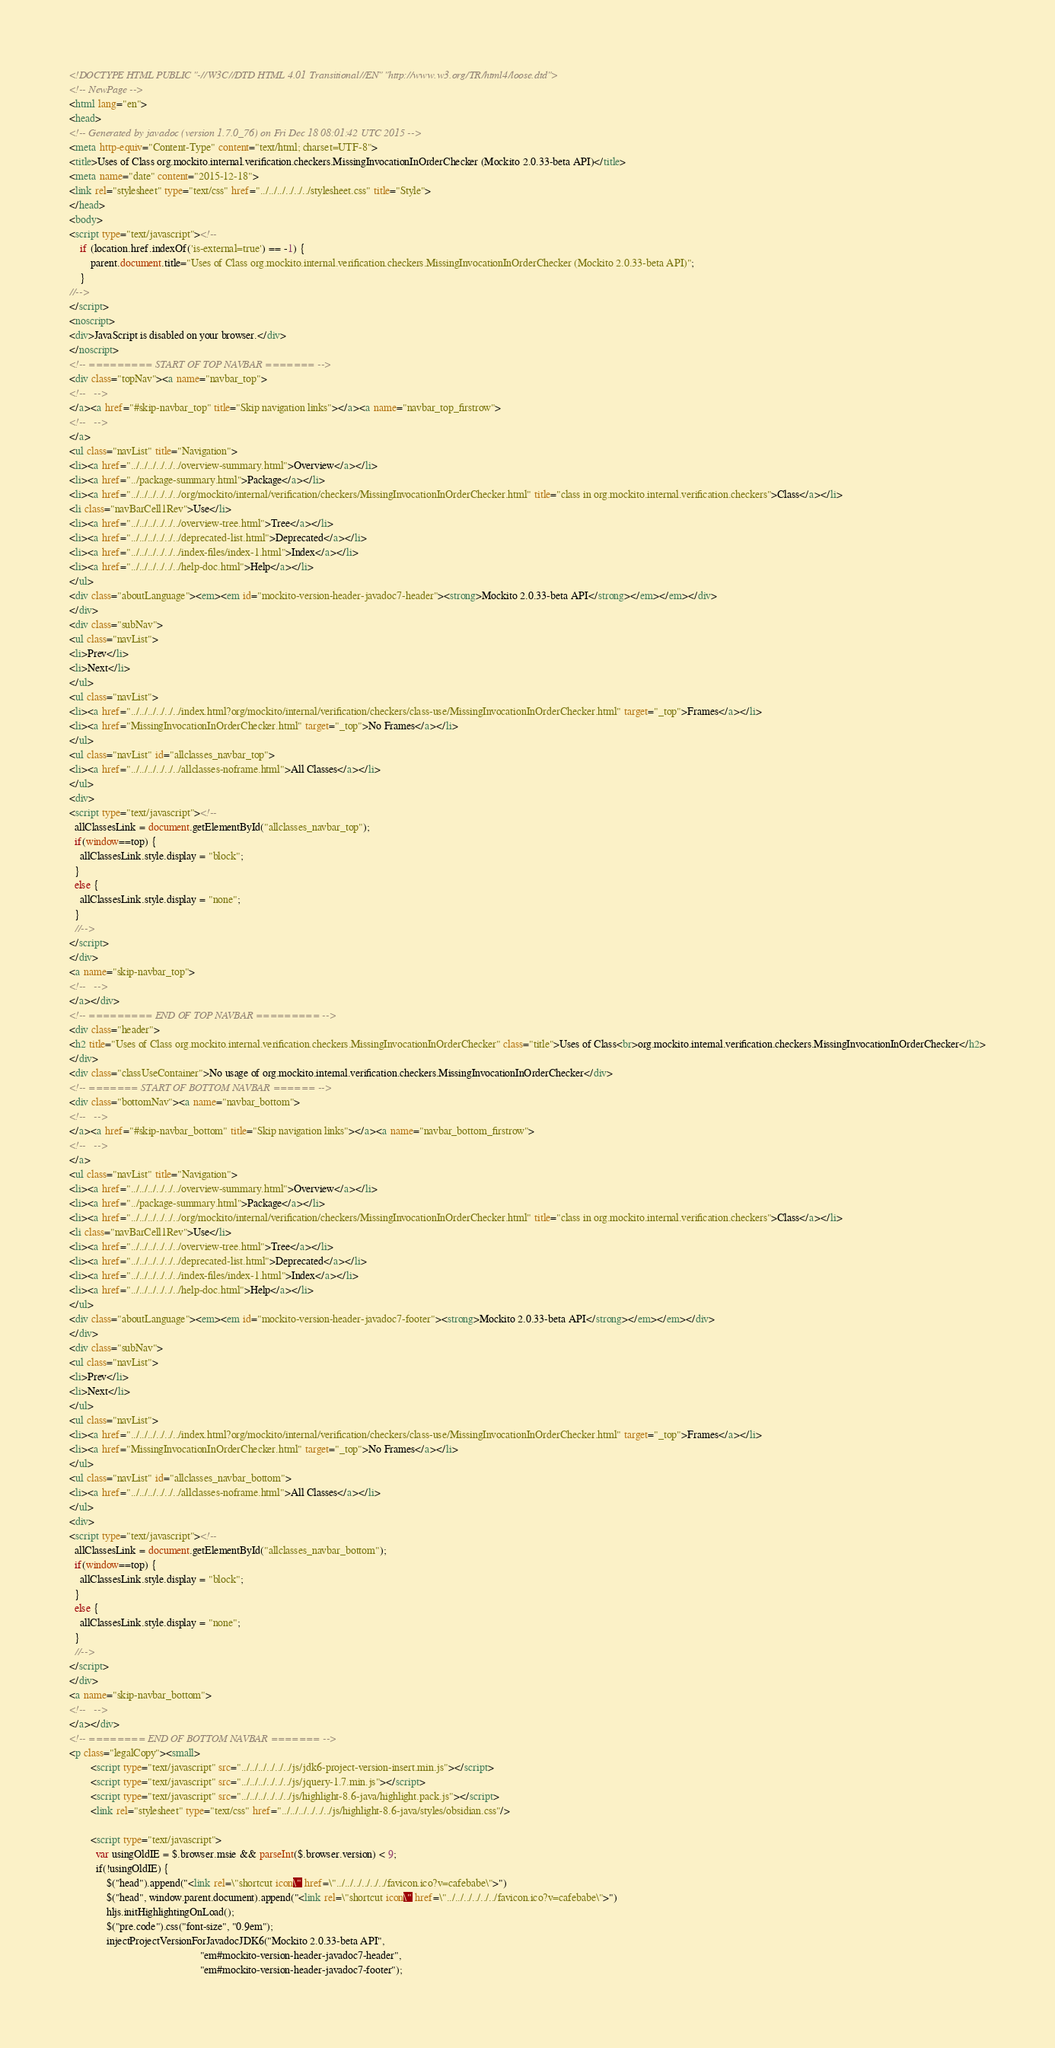Convert code to text. <code><loc_0><loc_0><loc_500><loc_500><_HTML_><!DOCTYPE HTML PUBLIC "-//W3C//DTD HTML 4.01 Transitional//EN" "http://www.w3.org/TR/html4/loose.dtd">
<!-- NewPage -->
<html lang="en">
<head>
<!-- Generated by javadoc (version 1.7.0_76) on Fri Dec 18 08:01:42 UTC 2015 -->
<meta http-equiv="Content-Type" content="text/html; charset=UTF-8">
<title>Uses of Class org.mockito.internal.verification.checkers.MissingInvocationInOrderChecker (Mockito 2.0.33-beta API)</title>
<meta name="date" content="2015-12-18">
<link rel="stylesheet" type="text/css" href="../../../../../../stylesheet.css" title="Style">
</head>
<body>
<script type="text/javascript"><!--
    if (location.href.indexOf('is-external=true') == -1) {
        parent.document.title="Uses of Class org.mockito.internal.verification.checkers.MissingInvocationInOrderChecker (Mockito 2.0.33-beta API)";
    }
//-->
</script>
<noscript>
<div>JavaScript is disabled on your browser.</div>
</noscript>
<!-- ========= START OF TOP NAVBAR ======= -->
<div class="topNav"><a name="navbar_top">
<!--   -->
</a><a href="#skip-navbar_top" title="Skip navigation links"></a><a name="navbar_top_firstrow">
<!--   -->
</a>
<ul class="navList" title="Navigation">
<li><a href="../../../../../../overview-summary.html">Overview</a></li>
<li><a href="../package-summary.html">Package</a></li>
<li><a href="../../../../../../org/mockito/internal/verification/checkers/MissingInvocationInOrderChecker.html" title="class in org.mockito.internal.verification.checkers">Class</a></li>
<li class="navBarCell1Rev">Use</li>
<li><a href="../../../../../../overview-tree.html">Tree</a></li>
<li><a href="../../../../../../deprecated-list.html">Deprecated</a></li>
<li><a href="../../../../../../index-files/index-1.html">Index</a></li>
<li><a href="../../../../../../help-doc.html">Help</a></li>
</ul>
<div class="aboutLanguage"><em><em id="mockito-version-header-javadoc7-header"><strong>Mockito 2.0.33-beta API</strong></em></em></div>
</div>
<div class="subNav">
<ul class="navList">
<li>Prev</li>
<li>Next</li>
</ul>
<ul class="navList">
<li><a href="../../../../../../index.html?org/mockito/internal/verification/checkers/class-use/MissingInvocationInOrderChecker.html" target="_top">Frames</a></li>
<li><a href="MissingInvocationInOrderChecker.html" target="_top">No Frames</a></li>
</ul>
<ul class="navList" id="allclasses_navbar_top">
<li><a href="../../../../../../allclasses-noframe.html">All Classes</a></li>
</ul>
<div>
<script type="text/javascript"><!--
  allClassesLink = document.getElementById("allclasses_navbar_top");
  if(window==top) {
    allClassesLink.style.display = "block";
  }
  else {
    allClassesLink.style.display = "none";
  }
  //-->
</script>
</div>
<a name="skip-navbar_top">
<!--   -->
</a></div>
<!-- ========= END OF TOP NAVBAR ========= -->
<div class="header">
<h2 title="Uses of Class org.mockito.internal.verification.checkers.MissingInvocationInOrderChecker" class="title">Uses of Class<br>org.mockito.internal.verification.checkers.MissingInvocationInOrderChecker</h2>
</div>
<div class="classUseContainer">No usage of org.mockito.internal.verification.checkers.MissingInvocationInOrderChecker</div>
<!-- ======= START OF BOTTOM NAVBAR ====== -->
<div class="bottomNav"><a name="navbar_bottom">
<!--   -->
</a><a href="#skip-navbar_bottom" title="Skip navigation links"></a><a name="navbar_bottom_firstrow">
<!--   -->
</a>
<ul class="navList" title="Navigation">
<li><a href="../../../../../../overview-summary.html">Overview</a></li>
<li><a href="../package-summary.html">Package</a></li>
<li><a href="../../../../../../org/mockito/internal/verification/checkers/MissingInvocationInOrderChecker.html" title="class in org.mockito.internal.verification.checkers">Class</a></li>
<li class="navBarCell1Rev">Use</li>
<li><a href="../../../../../../overview-tree.html">Tree</a></li>
<li><a href="../../../../../../deprecated-list.html">Deprecated</a></li>
<li><a href="../../../../../../index-files/index-1.html">Index</a></li>
<li><a href="../../../../../../help-doc.html">Help</a></li>
</ul>
<div class="aboutLanguage"><em><em id="mockito-version-header-javadoc7-footer"><strong>Mockito 2.0.33-beta API</strong></em></em></div>
</div>
<div class="subNav">
<ul class="navList">
<li>Prev</li>
<li>Next</li>
</ul>
<ul class="navList">
<li><a href="../../../../../../index.html?org/mockito/internal/verification/checkers/class-use/MissingInvocationInOrderChecker.html" target="_top">Frames</a></li>
<li><a href="MissingInvocationInOrderChecker.html" target="_top">No Frames</a></li>
</ul>
<ul class="navList" id="allclasses_navbar_bottom">
<li><a href="../../../../../../allclasses-noframe.html">All Classes</a></li>
</ul>
<div>
<script type="text/javascript"><!--
  allClassesLink = document.getElementById("allclasses_navbar_bottom");
  if(window==top) {
    allClassesLink.style.display = "block";
  }
  else {
    allClassesLink.style.display = "none";
  }
  //-->
</script>
</div>
<a name="skip-navbar_bottom">
<!--   -->
</a></div>
<!-- ======== END OF BOTTOM NAVBAR ======= -->
<p class="legalCopy"><small>
        <script type="text/javascript" src="../../../../../../js/jdk6-project-version-insert.min.js"></script>
        <script type="text/javascript" src="../../../../../../js/jquery-1.7.min.js"></script>
        <script type="text/javascript" src="../../../../../../js/highlight-8.6-java/highlight.pack.js"></script>
        <link rel="stylesheet" type="text/css" href="../../../../../../js/highlight-8.6-java/styles/obsidian.css"/>

        <script type="text/javascript">
          var usingOldIE = $.browser.msie && parseInt($.browser.version) < 9;
          if(!usingOldIE) {
              $("head").append("<link rel=\"shortcut icon\" href=\"../../../../../../favicon.ico?v=cafebabe\">")
              $("head", window.parent.document).append("<link rel=\"shortcut icon\" href=\"../../../../../../favicon.ico?v=cafebabe\">")
              hljs.initHighlightingOnLoad();
              $("pre.code").css("font-size", "0.9em");
              injectProjectVersionForJavadocJDK6("Mockito 2.0.33-beta API",
                                                 "em#mockito-version-header-javadoc7-header",
                                                 "em#mockito-version-header-javadoc7-footer");</code> 